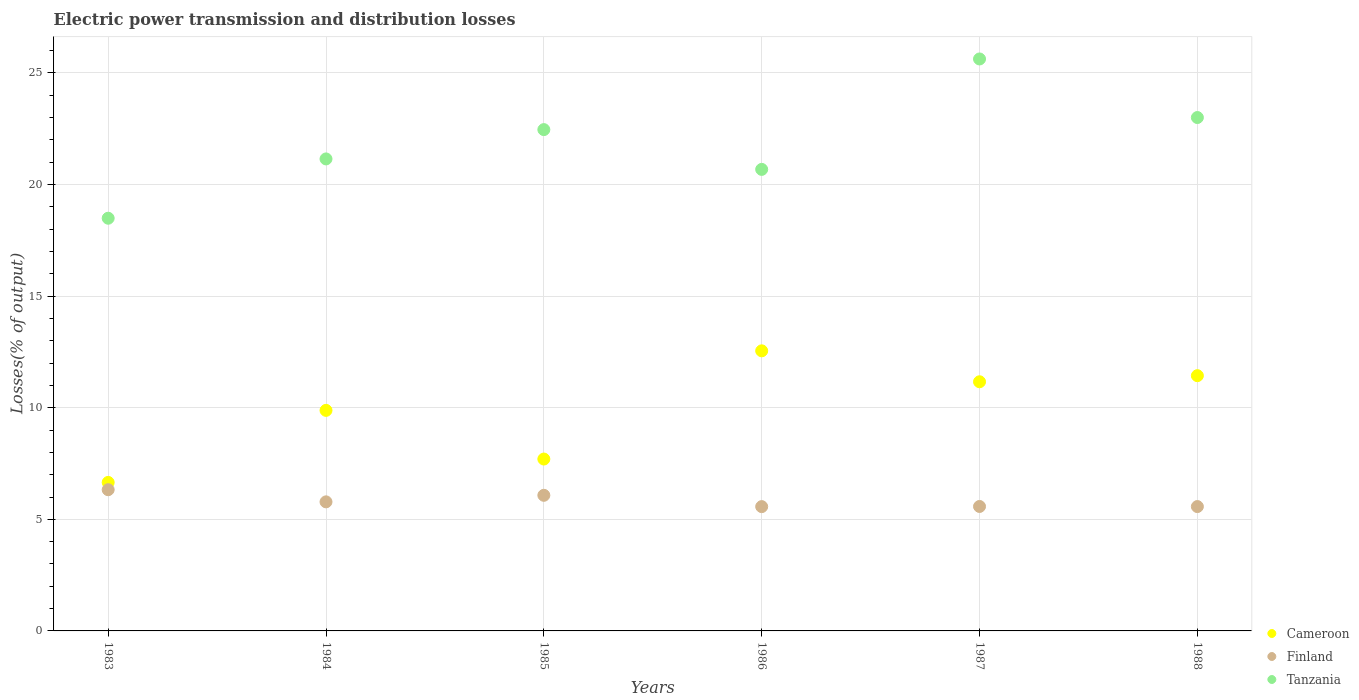What is the electric power transmission and distribution losses in Cameroon in 1987?
Ensure brevity in your answer.  11.16. Across all years, what is the maximum electric power transmission and distribution losses in Finland?
Your response must be concise. 6.33. Across all years, what is the minimum electric power transmission and distribution losses in Tanzania?
Keep it short and to the point. 18.49. What is the total electric power transmission and distribution losses in Finland in the graph?
Your answer should be very brief. 34.91. What is the difference between the electric power transmission and distribution losses in Finland in 1986 and that in 1987?
Your response must be concise. -0.01. What is the difference between the electric power transmission and distribution losses in Finland in 1985 and the electric power transmission and distribution losses in Cameroon in 1983?
Your response must be concise. -0.58. What is the average electric power transmission and distribution losses in Cameroon per year?
Ensure brevity in your answer.  9.9. In the year 1984, what is the difference between the electric power transmission and distribution losses in Cameroon and electric power transmission and distribution losses in Finland?
Your answer should be compact. 4.1. In how many years, is the electric power transmission and distribution losses in Cameroon greater than 4 %?
Ensure brevity in your answer.  6. What is the ratio of the electric power transmission and distribution losses in Cameroon in 1983 to that in 1988?
Offer a very short reply. 0.58. Is the electric power transmission and distribution losses in Tanzania in 1986 less than that in 1987?
Ensure brevity in your answer.  Yes. Is the difference between the electric power transmission and distribution losses in Cameroon in 1986 and 1988 greater than the difference between the electric power transmission and distribution losses in Finland in 1986 and 1988?
Your response must be concise. Yes. What is the difference between the highest and the second highest electric power transmission and distribution losses in Finland?
Provide a short and direct response. 0.25. What is the difference between the highest and the lowest electric power transmission and distribution losses in Cameroon?
Provide a succinct answer. 5.9. In how many years, is the electric power transmission and distribution losses in Cameroon greater than the average electric power transmission and distribution losses in Cameroon taken over all years?
Your answer should be very brief. 3. Is it the case that in every year, the sum of the electric power transmission and distribution losses in Cameroon and electric power transmission and distribution losses in Finland  is greater than the electric power transmission and distribution losses in Tanzania?
Make the answer very short. No. Does the electric power transmission and distribution losses in Cameroon monotonically increase over the years?
Your answer should be compact. No. Is the electric power transmission and distribution losses in Finland strictly greater than the electric power transmission and distribution losses in Tanzania over the years?
Ensure brevity in your answer.  No. What is the difference between two consecutive major ticks on the Y-axis?
Provide a succinct answer. 5. Does the graph contain any zero values?
Make the answer very short. No. Does the graph contain grids?
Make the answer very short. Yes. Where does the legend appear in the graph?
Your answer should be very brief. Bottom right. How are the legend labels stacked?
Your answer should be very brief. Vertical. What is the title of the graph?
Make the answer very short. Electric power transmission and distribution losses. What is the label or title of the Y-axis?
Keep it short and to the point. Losses(% of output). What is the Losses(% of output) of Cameroon in 1983?
Provide a short and direct response. 6.65. What is the Losses(% of output) in Finland in 1983?
Ensure brevity in your answer.  6.33. What is the Losses(% of output) of Tanzania in 1983?
Offer a terse response. 18.49. What is the Losses(% of output) of Cameroon in 1984?
Your response must be concise. 9.88. What is the Losses(% of output) in Finland in 1984?
Make the answer very short. 5.78. What is the Losses(% of output) in Tanzania in 1984?
Give a very brief answer. 21.15. What is the Losses(% of output) of Cameroon in 1985?
Keep it short and to the point. 7.7. What is the Losses(% of output) of Finland in 1985?
Keep it short and to the point. 6.08. What is the Losses(% of output) in Tanzania in 1985?
Your answer should be very brief. 22.46. What is the Losses(% of output) of Cameroon in 1986?
Make the answer very short. 12.55. What is the Losses(% of output) of Finland in 1986?
Your answer should be very brief. 5.57. What is the Losses(% of output) in Tanzania in 1986?
Offer a very short reply. 20.68. What is the Losses(% of output) in Cameroon in 1987?
Provide a succinct answer. 11.16. What is the Losses(% of output) of Finland in 1987?
Provide a short and direct response. 5.58. What is the Losses(% of output) in Tanzania in 1987?
Keep it short and to the point. 25.63. What is the Losses(% of output) in Cameroon in 1988?
Your response must be concise. 11.44. What is the Losses(% of output) of Finland in 1988?
Keep it short and to the point. 5.57. What is the Losses(% of output) of Tanzania in 1988?
Make the answer very short. 23. Across all years, what is the maximum Losses(% of output) in Cameroon?
Make the answer very short. 12.55. Across all years, what is the maximum Losses(% of output) in Finland?
Provide a short and direct response. 6.33. Across all years, what is the maximum Losses(% of output) in Tanzania?
Your answer should be compact. 25.63. Across all years, what is the minimum Losses(% of output) in Cameroon?
Offer a very short reply. 6.65. Across all years, what is the minimum Losses(% of output) of Finland?
Make the answer very short. 5.57. Across all years, what is the minimum Losses(% of output) in Tanzania?
Your answer should be very brief. 18.49. What is the total Losses(% of output) of Cameroon in the graph?
Provide a short and direct response. 59.39. What is the total Losses(% of output) of Finland in the graph?
Provide a short and direct response. 34.91. What is the total Losses(% of output) in Tanzania in the graph?
Provide a succinct answer. 131.42. What is the difference between the Losses(% of output) in Cameroon in 1983 and that in 1984?
Offer a terse response. -3.23. What is the difference between the Losses(% of output) of Finland in 1983 and that in 1984?
Provide a succinct answer. 0.54. What is the difference between the Losses(% of output) in Tanzania in 1983 and that in 1984?
Your answer should be very brief. -2.66. What is the difference between the Losses(% of output) in Cameroon in 1983 and that in 1985?
Your response must be concise. -1.05. What is the difference between the Losses(% of output) in Finland in 1983 and that in 1985?
Offer a very short reply. 0.25. What is the difference between the Losses(% of output) of Tanzania in 1983 and that in 1985?
Give a very brief answer. -3.97. What is the difference between the Losses(% of output) of Cameroon in 1983 and that in 1986?
Your answer should be compact. -5.9. What is the difference between the Losses(% of output) in Finland in 1983 and that in 1986?
Your response must be concise. 0.76. What is the difference between the Losses(% of output) in Tanzania in 1983 and that in 1986?
Your response must be concise. -2.19. What is the difference between the Losses(% of output) of Cameroon in 1983 and that in 1987?
Make the answer very short. -4.51. What is the difference between the Losses(% of output) in Finland in 1983 and that in 1987?
Your response must be concise. 0.75. What is the difference between the Losses(% of output) of Tanzania in 1983 and that in 1987?
Ensure brevity in your answer.  -7.14. What is the difference between the Losses(% of output) in Cameroon in 1983 and that in 1988?
Your response must be concise. -4.78. What is the difference between the Losses(% of output) in Finland in 1983 and that in 1988?
Your answer should be compact. 0.76. What is the difference between the Losses(% of output) of Tanzania in 1983 and that in 1988?
Give a very brief answer. -4.51. What is the difference between the Losses(% of output) of Cameroon in 1984 and that in 1985?
Make the answer very short. 2.18. What is the difference between the Losses(% of output) in Finland in 1984 and that in 1985?
Your answer should be compact. -0.29. What is the difference between the Losses(% of output) in Tanzania in 1984 and that in 1985?
Keep it short and to the point. -1.31. What is the difference between the Losses(% of output) in Cameroon in 1984 and that in 1986?
Provide a succinct answer. -2.67. What is the difference between the Losses(% of output) of Finland in 1984 and that in 1986?
Make the answer very short. 0.21. What is the difference between the Losses(% of output) in Tanzania in 1984 and that in 1986?
Offer a terse response. 0.47. What is the difference between the Losses(% of output) in Cameroon in 1984 and that in 1987?
Ensure brevity in your answer.  -1.28. What is the difference between the Losses(% of output) in Finland in 1984 and that in 1987?
Provide a short and direct response. 0.21. What is the difference between the Losses(% of output) in Tanzania in 1984 and that in 1987?
Make the answer very short. -4.48. What is the difference between the Losses(% of output) of Cameroon in 1984 and that in 1988?
Offer a very short reply. -1.55. What is the difference between the Losses(% of output) of Finland in 1984 and that in 1988?
Your answer should be compact. 0.21. What is the difference between the Losses(% of output) in Tanzania in 1984 and that in 1988?
Keep it short and to the point. -1.85. What is the difference between the Losses(% of output) of Cameroon in 1985 and that in 1986?
Offer a terse response. -4.85. What is the difference between the Losses(% of output) in Finland in 1985 and that in 1986?
Provide a short and direct response. 0.51. What is the difference between the Losses(% of output) in Tanzania in 1985 and that in 1986?
Your answer should be compact. 1.78. What is the difference between the Losses(% of output) in Cameroon in 1985 and that in 1987?
Make the answer very short. -3.46. What is the difference between the Losses(% of output) in Finland in 1985 and that in 1987?
Your answer should be very brief. 0.5. What is the difference between the Losses(% of output) in Tanzania in 1985 and that in 1987?
Ensure brevity in your answer.  -3.17. What is the difference between the Losses(% of output) of Cameroon in 1985 and that in 1988?
Give a very brief answer. -3.74. What is the difference between the Losses(% of output) in Finland in 1985 and that in 1988?
Offer a terse response. 0.5. What is the difference between the Losses(% of output) of Tanzania in 1985 and that in 1988?
Give a very brief answer. -0.54. What is the difference between the Losses(% of output) of Cameroon in 1986 and that in 1987?
Offer a terse response. 1.39. What is the difference between the Losses(% of output) in Finland in 1986 and that in 1987?
Provide a short and direct response. -0.01. What is the difference between the Losses(% of output) of Tanzania in 1986 and that in 1987?
Provide a succinct answer. -4.95. What is the difference between the Losses(% of output) of Cameroon in 1986 and that in 1988?
Offer a very short reply. 1.11. What is the difference between the Losses(% of output) in Finland in 1986 and that in 1988?
Offer a terse response. -0. What is the difference between the Losses(% of output) of Tanzania in 1986 and that in 1988?
Your response must be concise. -2.32. What is the difference between the Losses(% of output) of Cameroon in 1987 and that in 1988?
Offer a very short reply. -0.27. What is the difference between the Losses(% of output) of Finland in 1987 and that in 1988?
Ensure brevity in your answer.  0. What is the difference between the Losses(% of output) in Tanzania in 1987 and that in 1988?
Provide a short and direct response. 2.62. What is the difference between the Losses(% of output) of Cameroon in 1983 and the Losses(% of output) of Finland in 1984?
Make the answer very short. 0.87. What is the difference between the Losses(% of output) of Cameroon in 1983 and the Losses(% of output) of Tanzania in 1984?
Make the answer very short. -14.5. What is the difference between the Losses(% of output) of Finland in 1983 and the Losses(% of output) of Tanzania in 1984?
Provide a short and direct response. -14.82. What is the difference between the Losses(% of output) of Cameroon in 1983 and the Losses(% of output) of Finland in 1985?
Offer a terse response. 0.58. What is the difference between the Losses(% of output) of Cameroon in 1983 and the Losses(% of output) of Tanzania in 1985?
Keep it short and to the point. -15.81. What is the difference between the Losses(% of output) of Finland in 1983 and the Losses(% of output) of Tanzania in 1985?
Your answer should be very brief. -16.14. What is the difference between the Losses(% of output) of Cameroon in 1983 and the Losses(% of output) of Finland in 1986?
Your answer should be compact. 1.08. What is the difference between the Losses(% of output) of Cameroon in 1983 and the Losses(% of output) of Tanzania in 1986?
Your response must be concise. -14.03. What is the difference between the Losses(% of output) of Finland in 1983 and the Losses(% of output) of Tanzania in 1986?
Ensure brevity in your answer.  -14.35. What is the difference between the Losses(% of output) in Cameroon in 1983 and the Losses(% of output) in Finland in 1987?
Keep it short and to the point. 1.08. What is the difference between the Losses(% of output) of Cameroon in 1983 and the Losses(% of output) of Tanzania in 1987?
Keep it short and to the point. -18.97. What is the difference between the Losses(% of output) of Finland in 1983 and the Losses(% of output) of Tanzania in 1987?
Offer a terse response. -19.3. What is the difference between the Losses(% of output) of Cameroon in 1983 and the Losses(% of output) of Finland in 1988?
Offer a very short reply. 1.08. What is the difference between the Losses(% of output) of Cameroon in 1983 and the Losses(% of output) of Tanzania in 1988?
Your response must be concise. -16.35. What is the difference between the Losses(% of output) in Finland in 1983 and the Losses(% of output) in Tanzania in 1988?
Ensure brevity in your answer.  -16.68. What is the difference between the Losses(% of output) in Cameroon in 1984 and the Losses(% of output) in Finland in 1985?
Provide a short and direct response. 3.81. What is the difference between the Losses(% of output) in Cameroon in 1984 and the Losses(% of output) in Tanzania in 1985?
Your response must be concise. -12.58. What is the difference between the Losses(% of output) in Finland in 1984 and the Losses(% of output) in Tanzania in 1985?
Offer a very short reply. -16.68. What is the difference between the Losses(% of output) in Cameroon in 1984 and the Losses(% of output) in Finland in 1986?
Your answer should be very brief. 4.31. What is the difference between the Losses(% of output) of Cameroon in 1984 and the Losses(% of output) of Tanzania in 1986?
Provide a short and direct response. -10.8. What is the difference between the Losses(% of output) in Finland in 1984 and the Losses(% of output) in Tanzania in 1986?
Your answer should be compact. -14.9. What is the difference between the Losses(% of output) in Cameroon in 1984 and the Losses(% of output) in Finland in 1987?
Your response must be concise. 4.31. What is the difference between the Losses(% of output) of Cameroon in 1984 and the Losses(% of output) of Tanzania in 1987?
Provide a short and direct response. -15.75. What is the difference between the Losses(% of output) in Finland in 1984 and the Losses(% of output) in Tanzania in 1987?
Offer a very short reply. -19.85. What is the difference between the Losses(% of output) of Cameroon in 1984 and the Losses(% of output) of Finland in 1988?
Offer a terse response. 4.31. What is the difference between the Losses(% of output) in Cameroon in 1984 and the Losses(% of output) in Tanzania in 1988?
Offer a terse response. -13.12. What is the difference between the Losses(% of output) of Finland in 1984 and the Losses(% of output) of Tanzania in 1988?
Provide a short and direct response. -17.22. What is the difference between the Losses(% of output) of Cameroon in 1985 and the Losses(% of output) of Finland in 1986?
Provide a short and direct response. 2.13. What is the difference between the Losses(% of output) in Cameroon in 1985 and the Losses(% of output) in Tanzania in 1986?
Keep it short and to the point. -12.98. What is the difference between the Losses(% of output) in Finland in 1985 and the Losses(% of output) in Tanzania in 1986?
Provide a short and direct response. -14.6. What is the difference between the Losses(% of output) in Cameroon in 1985 and the Losses(% of output) in Finland in 1987?
Keep it short and to the point. 2.13. What is the difference between the Losses(% of output) in Cameroon in 1985 and the Losses(% of output) in Tanzania in 1987?
Give a very brief answer. -17.93. What is the difference between the Losses(% of output) in Finland in 1985 and the Losses(% of output) in Tanzania in 1987?
Make the answer very short. -19.55. What is the difference between the Losses(% of output) of Cameroon in 1985 and the Losses(% of output) of Finland in 1988?
Your response must be concise. 2.13. What is the difference between the Losses(% of output) in Cameroon in 1985 and the Losses(% of output) in Tanzania in 1988?
Provide a succinct answer. -15.3. What is the difference between the Losses(% of output) in Finland in 1985 and the Losses(% of output) in Tanzania in 1988?
Keep it short and to the point. -16.93. What is the difference between the Losses(% of output) of Cameroon in 1986 and the Losses(% of output) of Finland in 1987?
Make the answer very short. 6.97. What is the difference between the Losses(% of output) of Cameroon in 1986 and the Losses(% of output) of Tanzania in 1987?
Give a very brief answer. -13.08. What is the difference between the Losses(% of output) in Finland in 1986 and the Losses(% of output) in Tanzania in 1987?
Offer a terse response. -20.06. What is the difference between the Losses(% of output) of Cameroon in 1986 and the Losses(% of output) of Finland in 1988?
Ensure brevity in your answer.  6.98. What is the difference between the Losses(% of output) in Cameroon in 1986 and the Losses(% of output) in Tanzania in 1988?
Make the answer very short. -10.45. What is the difference between the Losses(% of output) of Finland in 1986 and the Losses(% of output) of Tanzania in 1988?
Make the answer very short. -17.43. What is the difference between the Losses(% of output) of Cameroon in 1987 and the Losses(% of output) of Finland in 1988?
Provide a succinct answer. 5.59. What is the difference between the Losses(% of output) in Cameroon in 1987 and the Losses(% of output) in Tanzania in 1988?
Your answer should be very brief. -11.84. What is the difference between the Losses(% of output) in Finland in 1987 and the Losses(% of output) in Tanzania in 1988?
Ensure brevity in your answer.  -17.43. What is the average Losses(% of output) in Cameroon per year?
Keep it short and to the point. 9.9. What is the average Losses(% of output) in Finland per year?
Provide a short and direct response. 5.82. What is the average Losses(% of output) of Tanzania per year?
Provide a short and direct response. 21.9. In the year 1983, what is the difference between the Losses(% of output) of Cameroon and Losses(% of output) of Finland?
Your response must be concise. 0.33. In the year 1983, what is the difference between the Losses(% of output) of Cameroon and Losses(% of output) of Tanzania?
Provide a succinct answer. -11.84. In the year 1983, what is the difference between the Losses(% of output) of Finland and Losses(% of output) of Tanzania?
Your answer should be very brief. -12.16. In the year 1984, what is the difference between the Losses(% of output) in Cameroon and Losses(% of output) in Finland?
Provide a short and direct response. 4.1. In the year 1984, what is the difference between the Losses(% of output) in Cameroon and Losses(% of output) in Tanzania?
Offer a very short reply. -11.27. In the year 1984, what is the difference between the Losses(% of output) of Finland and Losses(% of output) of Tanzania?
Provide a succinct answer. -15.37. In the year 1985, what is the difference between the Losses(% of output) in Cameroon and Losses(% of output) in Finland?
Offer a terse response. 1.63. In the year 1985, what is the difference between the Losses(% of output) in Cameroon and Losses(% of output) in Tanzania?
Your response must be concise. -14.76. In the year 1985, what is the difference between the Losses(% of output) of Finland and Losses(% of output) of Tanzania?
Offer a terse response. -16.39. In the year 1986, what is the difference between the Losses(% of output) of Cameroon and Losses(% of output) of Finland?
Offer a terse response. 6.98. In the year 1986, what is the difference between the Losses(% of output) in Cameroon and Losses(% of output) in Tanzania?
Your response must be concise. -8.13. In the year 1986, what is the difference between the Losses(% of output) of Finland and Losses(% of output) of Tanzania?
Your answer should be compact. -15.11. In the year 1987, what is the difference between the Losses(% of output) of Cameroon and Losses(% of output) of Finland?
Provide a succinct answer. 5.59. In the year 1987, what is the difference between the Losses(% of output) of Cameroon and Losses(% of output) of Tanzania?
Keep it short and to the point. -14.46. In the year 1987, what is the difference between the Losses(% of output) in Finland and Losses(% of output) in Tanzania?
Give a very brief answer. -20.05. In the year 1988, what is the difference between the Losses(% of output) in Cameroon and Losses(% of output) in Finland?
Offer a very short reply. 5.87. In the year 1988, what is the difference between the Losses(% of output) of Cameroon and Losses(% of output) of Tanzania?
Your answer should be compact. -11.57. In the year 1988, what is the difference between the Losses(% of output) of Finland and Losses(% of output) of Tanzania?
Give a very brief answer. -17.43. What is the ratio of the Losses(% of output) of Cameroon in 1983 to that in 1984?
Offer a terse response. 0.67. What is the ratio of the Losses(% of output) in Finland in 1983 to that in 1984?
Keep it short and to the point. 1.09. What is the ratio of the Losses(% of output) in Tanzania in 1983 to that in 1984?
Make the answer very short. 0.87. What is the ratio of the Losses(% of output) of Cameroon in 1983 to that in 1985?
Offer a terse response. 0.86. What is the ratio of the Losses(% of output) in Finland in 1983 to that in 1985?
Give a very brief answer. 1.04. What is the ratio of the Losses(% of output) in Tanzania in 1983 to that in 1985?
Keep it short and to the point. 0.82. What is the ratio of the Losses(% of output) in Cameroon in 1983 to that in 1986?
Ensure brevity in your answer.  0.53. What is the ratio of the Losses(% of output) in Finland in 1983 to that in 1986?
Give a very brief answer. 1.14. What is the ratio of the Losses(% of output) in Tanzania in 1983 to that in 1986?
Ensure brevity in your answer.  0.89. What is the ratio of the Losses(% of output) of Cameroon in 1983 to that in 1987?
Give a very brief answer. 0.6. What is the ratio of the Losses(% of output) in Finland in 1983 to that in 1987?
Offer a terse response. 1.13. What is the ratio of the Losses(% of output) of Tanzania in 1983 to that in 1987?
Your answer should be compact. 0.72. What is the ratio of the Losses(% of output) of Cameroon in 1983 to that in 1988?
Offer a very short reply. 0.58. What is the ratio of the Losses(% of output) in Finland in 1983 to that in 1988?
Ensure brevity in your answer.  1.14. What is the ratio of the Losses(% of output) in Tanzania in 1983 to that in 1988?
Provide a succinct answer. 0.8. What is the ratio of the Losses(% of output) in Cameroon in 1984 to that in 1985?
Give a very brief answer. 1.28. What is the ratio of the Losses(% of output) of Finland in 1984 to that in 1985?
Make the answer very short. 0.95. What is the ratio of the Losses(% of output) of Tanzania in 1984 to that in 1985?
Offer a very short reply. 0.94. What is the ratio of the Losses(% of output) in Cameroon in 1984 to that in 1986?
Your answer should be compact. 0.79. What is the ratio of the Losses(% of output) in Finland in 1984 to that in 1986?
Ensure brevity in your answer.  1.04. What is the ratio of the Losses(% of output) of Tanzania in 1984 to that in 1986?
Offer a very short reply. 1.02. What is the ratio of the Losses(% of output) of Cameroon in 1984 to that in 1987?
Give a very brief answer. 0.89. What is the ratio of the Losses(% of output) of Tanzania in 1984 to that in 1987?
Provide a succinct answer. 0.83. What is the ratio of the Losses(% of output) in Cameroon in 1984 to that in 1988?
Provide a short and direct response. 0.86. What is the ratio of the Losses(% of output) of Finland in 1984 to that in 1988?
Offer a terse response. 1.04. What is the ratio of the Losses(% of output) in Tanzania in 1984 to that in 1988?
Make the answer very short. 0.92. What is the ratio of the Losses(% of output) of Cameroon in 1985 to that in 1986?
Ensure brevity in your answer.  0.61. What is the ratio of the Losses(% of output) in Finland in 1985 to that in 1986?
Offer a terse response. 1.09. What is the ratio of the Losses(% of output) of Tanzania in 1985 to that in 1986?
Offer a terse response. 1.09. What is the ratio of the Losses(% of output) of Cameroon in 1985 to that in 1987?
Offer a terse response. 0.69. What is the ratio of the Losses(% of output) of Finland in 1985 to that in 1987?
Offer a very short reply. 1.09. What is the ratio of the Losses(% of output) of Tanzania in 1985 to that in 1987?
Give a very brief answer. 0.88. What is the ratio of the Losses(% of output) of Cameroon in 1985 to that in 1988?
Keep it short and to the point. 0.67. What is the ratio of the Losses(% of output) in Finland in 1985 to that in 1988?
Provide a short and direct response. 1.09. What is the ratio of the Losses(% of output) of Tanzania in 1985 to that in 1988?
Your response must be concise. 0.98. What is the ratio of the Losses(% of output) of Cameroon in 1986 to that in 1987?
Ensure brevity in your answer.  1.12. What is the ratio of the Losses(% of output) in Tanzania in 1986 to that in 1987?
Keep it short and to the point. 0.81. What is the ratio of the Losses(% of output) of Cameroon in 1986 to that in 1988?
Ensure brevity in your answer.  1.1. What is the ratio of the Losses(% of output) of Tanzania in 1986 to that in 1988?
Make the answer very short. 0.9. What is the ratio of the Losses(% of output) of Cameroon in 1987 to that in 1988?
Offer a terse response. 0.98. What is the ratio of the Losses(% of output) in Finland in 1987 to that in 1988?
Your response must be concise. 1. What is the ratio of the Losses(% of output) of Tanzania in 1987 to that in 1988?
Offer a terse response. 1.11. What is the difference between the highest and the second highest Losses(% of output) of Cameroon?
Provide a short and direct response. 1.11. What is the difference between the highest and the second highest Losses(% of output) of Finland?
Your answer should be very brief. 0.25. What is the difference between the highest and the second highest Losses(% of output) in Tanzania?
Ensure brevity in your answer.  2.62. What is the difference between the highest and the lowest Losses(% of output) in Cameroon?
Your response must be concise. 5.9. What is the difference between the highest and the lowest Losses(% of output) of Finland?
Keep it short and to the point. 0.76. What is the difference between the highest and the lowest Losses(% of output) of Tanzania?
Your answer should be compact. 7.14. 